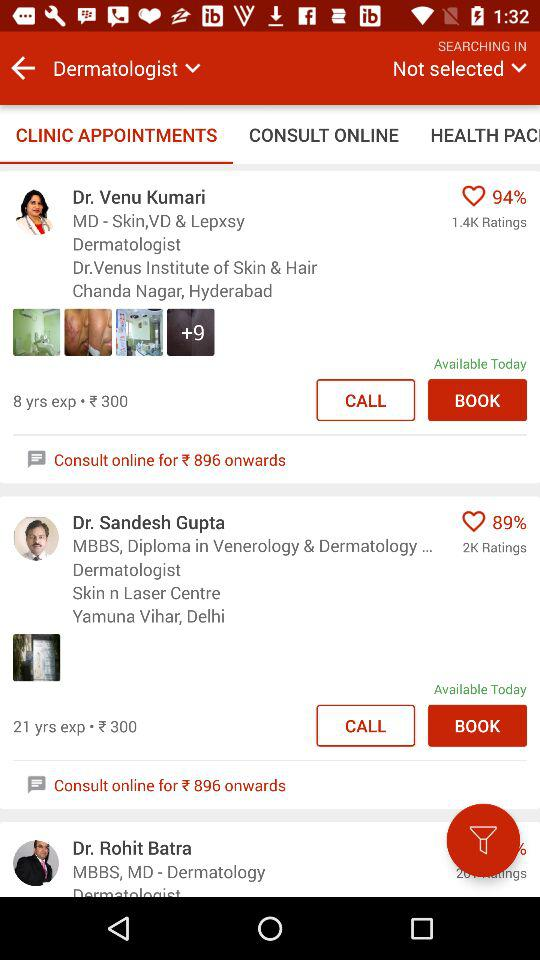What is the address of Dr. Sandesh Gupta? The address of Dr. Sandesh Gupta is Skin n Laser Centre, Yamuna Vihar, Delhi. 